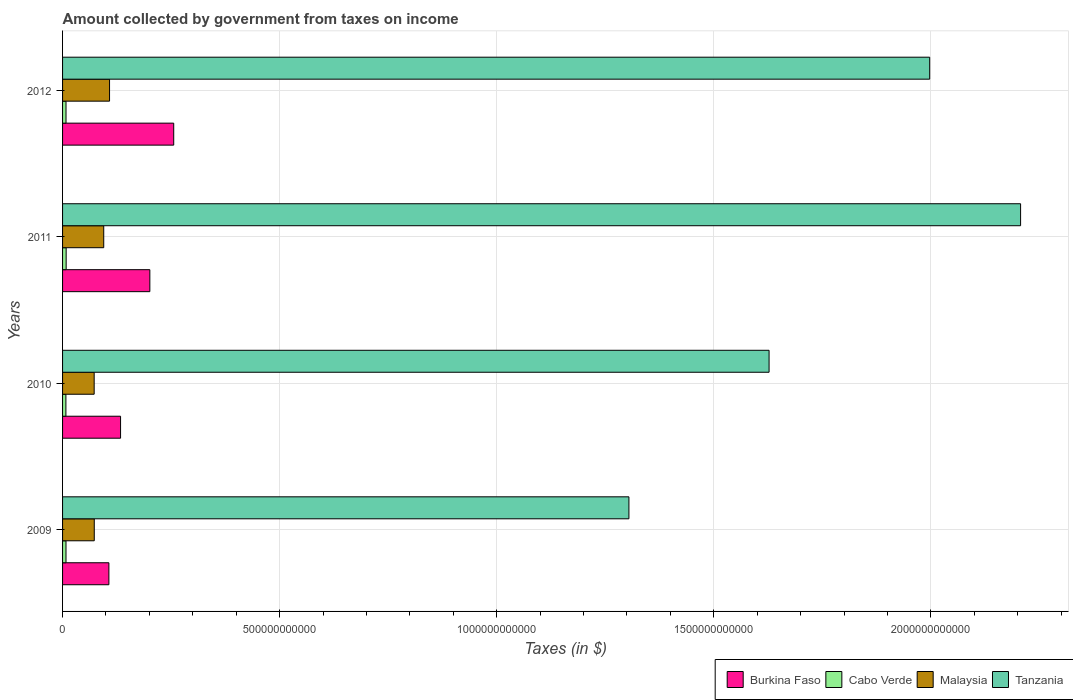How many different coloured bars are there?
Your response must be concise. 4. Are the number of bars per tick equal to the number of legend labels?
Your answer should be very brief. Yes. How many bars are there on the 4th tick from the top?
Your answer should be compact. 4. In how many cases, is the number of bars for a given year not equal to the number of legend labels?
Give a very brief answer. 0. What is the amount collected by government from taxes on income in Cabo Verde in 2011?
Provide a short and direct response. 8.28e+09. Across all years, what is the maximum amount collected by government from taxes on income in Malaysia?
Your answer should be compact. 1.08e+11. Across all years, what is the minimum amount collected by government from taxes on income in Burkina Faso?
Offer a very short reply. 1.07e+11. What is the total amount collected by government from taxes on income in Cabo Verde in the graph?
Your response must be concise. 3.18e+1. What is the difference between the amount collected by government from taxes on income in Malaysia in 2011 and that in 2012?
Provide a short and direct response. -1.34e+1. What is the difference between the amount collected by government from taxes on income in Cabo Verde in 2010 and the amount collected by government from taxes on income in Tanzania in 2009?
Your response must be concise. -1.30e+12. What is the average amount collected by government from taxes on income in Malaysia per year?
Ensure brevity in your answer.  8.72e+1. In the year 2012, what is the difference between the amount collected by government from taxes on income in Malaysia and amount collected by government from taxes on income in Burkina Faso?
Your answer should be compact. -1.48e+11. What is the ratio of the amount collected by government from taxes on income in Tanzania in 2010 to that in 2011?
Your answer should be compact. 0.74. What is the difference between the highest and the second highest amount collected by government from taxes on income in Burkina Faso?
Give a very brief answer. 5.50e+1. What is the difference between the highest and the lowest amount collected by government from taxes on income in Burkina Faso?
Your response must be concise. 1.49e+11. What does the 4th bar from the top in 2009 represents?
Give a very brief answer. Burkina Faso. What does the 3rd bar from the bottom in 2010 represents?
Give a very brief answer. Malaysia. Are all the bars in the graph horizontal?
Provide a succinct answer. Yes. How many years are there in the graph?
Your response must be concise. 4. What is the difference between two consecutive major ticks on the X-axis?
Provide a succinct answer. 5.00e+11. Does the graph contain any zero values?
Offer a very short reply. No. How many legend labels are there?
Your answer should be compact. 4. What is the title of the graph?
Your response must be concise. Amount collected by government from taxes on income. What is the label or title of the X-axis?
Provide a succinct answer. Taxes (in $). What is the label or title of the Y-axis?
Give a very brief answer. Years. What is the Taxes (in $) in Burkina Faso in 2009?
Offer a terse response. 1.07e+11. What is the Taxes (in $) in Cabo Verde in 2009?
Offer a terse response. 7.91e+09. What is the Taxes (in $) in Malaysia in 2009?
Offer a very short reply. 7.30e+1. What is the Taxes (in $) in Tanzania in 2009?
Keep it short and to the point. 1.30e+12. What is the Taxes (in $) of Burkina Faso in 2010?
Provide a succinct answer. 1.34e+11. What is the Taxes (in $) of Cabo Verde in 2010?
Offer a very short reply. 7.70e+09. What is the Taxes (in $) in Malaysia in 2010?
Offer a terse response. 7.28e+1. What is the Taxes (in $) of Tanzania in 2010?
Your answer should be compact. 1.63e+12. What is the Taxes (in $) of Burkina Faso in 2011?
Your answer should be very brief. 2.01e+11. What is the Taxes (in $) in Cabo Verde in 2011?
Your answer should be very brief. 8.28e+09. What is the Taxes (in $) of Malaysia in 2011?
Offer a terse response. 9.48e+1. What is the Taxes (in $) of Tanzania in 2011?
Your answer should be compact. 2.21e+12. What is the Taxes (in $) of Burkina Faso in 2012?
Your answer should be compact. 2.56e+11. What is the Taxes (in $) of Cabo Verde in 2012?
Make the answer very short. 7.94e+09. What is the Taxes (in $) of Malaysia in 2012?
Your response must be concise. 1.08e+11. What is the Taxes (in $) of Tanzania in 2012?
Provide a short and direct response. 2.00e+12. Across all years, what is the maximum Taxes (in $) of Burkina Faso?
Your answer should be compact. 2.56e+11. Across all years, what is the maximum Taxes (in $) of Cabo Verde?
Your answer should be very brief. 8.28e+09. Across all years, what is the maximum Taxes (in $) of Malaysia?
Your response must be concise. 1.08e+11. Across all years, what is the maximum Taxes (in $) in Tanzania?
Your response must be concise. 2.21e+12. Across all years, what is the minimum Taxes (in $) of Burkina Faso?
Provide a succinct answer. 1.07e+11. Across all years, what is the minimum Taxes (in $) of Cabo Verde?
Make the answer very short. 7.70e+09. Across all years, what is the minimum Taxes (in $) of Malaysia?
Make the answer very short. 7.28e+1. Across all years, what is the minimum Taxes (in $) of Tanzania?
Provide a succinct answer. 1.30e+12. What is the total Taxes (in $) in Burkina Faso in the graph?
Ensure brevity in your answer.  6.97e+11. What is the total Taxes (in $) in Cabo Verde in the graph?
Offer a terse response. 3.18e+1. What is the total Taxes (in $) in Malaysia in the graph?
Give a very brief answer. 3.49e+11. What is the total Taxes (in $) in Tanzania in the graph?
Offer a very short reply. 7.14e+12. What is the difference between the Taxes (in $) of Burkina Faso in 2009 and that in 2010?
Your response must be concise. -2.69e+1. What is the difference between the Taxes (in $) in Cabo Verde in 2009 and that in 2010?
Offer a very short reply. 2.10e+08. What is the difference between the Taxes (in $) in Malaysia in 2009 and that in 2010?
Ensure brevity in your answer.  2.37e+08. What is the difference between the Taxes (in $) of Tanzania in 2009 and that in 2010?
Your answer should be very brief. -3.23e+11. What is the difference between the Taxes (in $) in Burkina Faso in 2009 and that in 2011?
Provide a succinct answer. -9.43e+1. What is the difference between the Taxes (in $) of Cabo Verde in 2009 and that in 2011?
Give a very brief answer. -3.74e+08. What is the difference between the Taxes (in $) in Malaysia in 2009 and that in 2011?
Offer a terse response. -2.18e+1. What is the difference between the Taxes (in $) of Tanzania in 2009 and that in 2011?
Your answer should be compact. -9.02e+11. What is the difference between the Taxes (in $) of Burkina Faso in 2009 and that in 2012?
Your answer should be very brief. -1.49e+11. What is the difference between the Taxes (in $) of Cabo Verde in 2009 and that in 2012?
Provide a succinct answer. -2.87e+07. What is the difference between the Taxes (in $) of Malaysia in 2009 and that in 2012?
Offer a very short reply. -3.52e+1. What is the difference between the Taxes (in $) of Tanzania in 2009 and that in 2012?
Give a very brief answer. -6.93e+11. What is the difference between the Taxes (in $) in Burkina Faso in 2010 and that in 2011?
Offer a very short reply. -6.74e+1. What is the difference between the Taxes (in $) in Cabo Verde in 2010 and that in 2011?
Offer a very short reply. -5.84e+08. What is the difference between the Taxes (in $) in Malaysia in 2010 and that in 2011?
Make the answer very short. -2.21e+1. What is the difference between the Taxes (in $) of Tanzania in 2010 and that in 2011?
Your answer should be very brief. -5.79e+11. What is the difference between the Taxes (in $) of Burkina Faso in 2010 and that in 2012?
Keep it short and to the point. -1.22e+11. What is the difference between the Taxes (in $) of Cabo Verde in 2010 and that in 2012?
Offer a terse response. -2.39e+08. What is the difference between the Taxes (in $) in Malaysia in 2010 and that in 2012?
Make the answer very short. -3.54e+1. What is the difference between the Taxes (in $) in Tanzania in 2010 and that in 2012?
Your answer should be compact. -3.70e+11. What is the difference between the Taxes (in $) in Burkina Faso in 2011 and that in 2012?
Provide a succinct answer. -5.50e+1. What is the difference between the Taxes (in $) of Cabo Verde in 2011 and that in 2012?
Your response must be concise. 3.46e+08. What is the difference between the Taxes (in $) of Malaysia in 2011 and that in 2012?
Provide a short and direct response. -1.34e+1. What is the difference between the Taxes (in $) of Tanzania in 2011 and that in 2012?
Offer a terse response. 2.09e+11. What is the difference between the Taxes (in $) of Burkina Faso in 2009 and the Taxes (in $) of Cabo Verde in 2010?
Your response must be concise. 9.90e+1. What is the difference between the Taxes (in $) of Burkina Faso in 2009 and the Taxes (in $) of Malaysia in 2010?
Provide a succinct answer. 3.39e+1. What is the difference between the Taxes (in $) in Burkina Faso in 2009 and the Taxes (in $) in Tanzania in 2010?
Provide a short and direct response. -1.52e+12. What is the difference between the Taxes (in $) of Cabo Verde in 2009 and the Taxes (in $) of Malaysia in 2010?
Provide a succinct answer. -6.49e+1. What is the difference between the Taxes (in $) of Cabo Verde in 2009 and the Taxes (in $) of Tanzania in 2010?
Give a very brief answer. -1.62e+12. What is the difference between the Taxes (in $) in Malaysia in 2009 and the Taxes (in $) in Tanzania in 2010?
Ensure brevity in your answer.  -1.55e+12. What is the difference between the Taxes (in $) in Burkina Faso in 2009 and the Taxes (in $) in Cabo Verde in 2011?
Make the answer very short. 9.84e+1. What is the difference between the Taxes (in $) of Burkina Faso in 2009 and the Taxes (in $) of Malaysia in 2011?
Provide a succinct answer. 1.18e+1. What is the difference between the Taxes (in $) of Burkina Faso in 2009 and the Taxes (in $) of Tanzania in 2011?
Offer a very short reply. -2.10e+12. What is the difference between the Taxes (in $) in Cabo Verde in 2009 and the Taxes (in $) in Malaysia in 2011?
Your response must be concise. -8.69e+1. What is the difference between the Taxes (in $) in Cabo Verde in 2009 and the Taxes (in $) in Tanzania in 2011?
Keep it short and to the point. -2.20e+12. What is the difference between the Taxes (in $) in Malaysia in 2009 and the Taxes (in $) in Tanzania in 2011?
Your answer should be compact. -2.13e+12. What is the difference between the Taxes (in $) in Burkina Faso in 2009 and the Taxes (in $) in Cabo Verde in 2012?
Your answer should be very brief. 9.87e+1. What is the difference between the Taxes (in $) in Burkina Faso in 2009 and the Taxes (in $) in Malaysia in 2012?
Provide a short and direct response. -1.51e+09. What is the difference between the Taxes (in $) in Burkina Faso in 2009 and the Taxes (in $) in Tanzania in 2012?
Give a very brief answer. -1.89e+12. What is the difference between the Taxes (in $) of Cabo Verde in 2009 and the Taxes (in $) of Malaysia in 2012?
Provide a short and direct response. -1.00e+11. What is the difference between the Taxes (in $) of Cabo Verde in 2009 and the Taxes (in $) of Tanzania in 2012?
Your answer should be very brief. -1.99e+12. What is the difference between the Taxes (in $) in Malaysia in 2009 and the Taxes (in $) in Tanzania in 2012?
Make the answer very short. -1.92e+12. What is the difference between the Taxes (in $) in Burkina Faso in 2010 and the Taxes (in $) in Cabo Verde in 2011?
Offer a terse response. 1.25e+11. What is the difference between the Taxes (in $) in Burkina Faso in 2010 and the Taxes (in $) in Malaysia in 2011?
Your answer should be compact. 3.87e+1. What is the difference between the Taxes (in $) of Burkina Faso in 2010 and the Taxes (in $) of Tanzania in 2011?
Offer a terse response. -2.07e+12. What is the difference between the Taxes (in $) of Cabo Verde in 2010 and the Taxes (in $) of Malaysia in 2011?
Offer a very short reply. -8.71e+1. What is the difference between the Taxes (in $) in Cabo Verde in 2010 and the Taxes (in $) in Tanzania in 2011?
Give a very brief answer. -2.20e+12. What is the difference between the Taxes (in $) in Malaysia in 2010 and the Taxes (in $) in Tanzania in 2011?
Provide a short and direct response. -2.13e+12. What is the difference between the Taxes (in $) in Burkina Faso in 2010 and the Taxes (in $) in Cabo Verde in 2012?
Give a very brief answer. 1.26e+11. What is the difference between the Taxes (in $) of Burkina Faso in 2010 and the Taxes (in $) of Malaysia in 2012?
Your answer should be very brief. 2.54e+1. What is the difference between the Taxes (in $) in Burkina Faso in 2010 and the Taxes (in $) in Tanzania in 2012?
Your answer should be very brief. -1.86e+12. What is the difference between the Taxes (in $) of Cabo Verde in 2010 and the Taxes (in $) of Malaysia in 2012?
Provide a short and direct response. -1.00e+11. What is the difference between the Taxes (in $) of Cabo Verde in 2010 and the Taxes (in $) of Tanzania in 2012?
Your answer should be compact. -1.99e+12. What is the difference between the Taxes (in $) of Malaysia in 2010 and the Taxes (in $) of Tanzania in 2012?
Your answer should be compact. -1.92e+12. What is the difference between the Taxes (in $) of Burkina Faso in 2011 and the Taxes (in $) of Cabo Verde in 2012?
Provide a succinct answer. 1.93e+11. What is the difference between the Taxes (in $) in Burkina Faso in 2011 and the Taxes (in $) in Malaysia in 2012?
Provide a short and direct response. 9.28e+1. What is the difference between the Taxes (in $) in Burkina Faso in 2011 and the Taxes (in $) in Tanzania in 2012?
Provide a succinct answer. -1.80e+12. What is the difference between the Taxes (in $) of Cabo Verde in 2011 and the Taxes (in $) of Malaysia in 2012?
Offer a very short reply. -9.99e+1. What is the difference between the Taxes (in $) in Cabo Verde in 2011 and the Taxes (in $) in Tanzania in 2012?
Keep it short and to the point. -1.99e+12. What is the difference between the Taxes (in $) of Malaysia in 2011 and the Taxes (in $) of Tanzania in 2012?
Your answer should be compact. -1.90e+12. What is the average Taxes (in $) of Burkina Faso per year?
Your answer should be very brief. 1.74e+11. What is the average Taxes (in $) in Cabo Verde per year?
Offer a very short reply. 7.96e+09. What is the average Taxes (in $) in Malaysia per year?
Your answer should be compact. 8.72e+1. What is the average Taxes (in $) in Tanzania per year?
Your answer should be compact. 1.78e+12. In the year 2009, what is the difference between the Taxes (in $) in Burkina Faso and Taxes (in $) in Cabo Verde?
Provide a succinct answer. 9.88e+1. In the year 2009, what is the difference between the Taxes (in $) in Burkina Faso and Taxes (in $) in Malaysia?
Make the answer very short. 3.37e+1. In the year 2009, what is the difference between the Taxes (in $) of Burkina Faso and Taxes (in $) of Tanzania?
Provide a succinct answer. -1.20e+12. In the year 2009, what is the difference between the Taxes (in $) of Cabo Verde and Taxes (in $) of Malaysia?
Make the answer very short. -6.51e+1. In the year 2009, what is the difference between the Taxes (in $) in Cabo Verde and Taxes (in $) in Tanzania?
Your answer should be compact. -1.30e+12. In the year 2009, what is the difference between the Taxes (in $) in Malaysia and Taxes (in $) in Tanzania?
Give a very brief answer. -1.23e+12. In the year 2010, what is the difference between the Taxes (in $) of Burkina Faso and Taxes (in $) of Cabo Verde?
Your answer should be compact. 1.26e+11. In the year 2010, what is the difference between the Taxes (in $) of Burkina Faso and Taxes (in $) of Malaysia?
Offer a very short reply. 6.08e+1. In the year 2010, what is the difference between the Taxes (in $) in Burkina Faso and Taxes (in $) in Tanzania?
Offer a terse response. -1.49e+12. In the year 2010, what is the difference between the Taxes (in $) in Cabo Verde and Taxes (in $) in Malaysia?
Ensure brevity in your answer.  -6.51e+1. In the year 2010, what is the difference between the Taxes (in $) in Cabo Verde and Taxes (in $) in Tanzania?
Give a very brief answer. -1.62e+12. In the year 2010, what is the difference between the Taxes (in $) of Malaysia and Taxes (in $) of Tanzania?
Offer a terse response. -1.55e+12. In the year 2011, what is the difference between the Taxes (in $) in Burkina Faso and Taxes (in $) in Cabo Verde?
Offer a terse response. 1.93e+11. In the year 2011, what is the difference between the Taxes (in $) of Burkina Faso and Taxes (in $) of Malaysia?
Give a very brief answer. 1.06e+11. In the year 2011, what is the difference between the Taxes (in $) of Burkina Faso and Taxes (in $) of Tanzania?
Your answer should be very brief. -2.01e+12. In the year 2011, what is the difference between the Taxes (in $) in Cabo Verde and Taxes (in $) in Malaysia?
Offer a very short reply. -8.66e+1. In the year 2011, what is the difference between the Taxes (in $) of Cabo Verde and Taxes (in $) of Tanzania?
Offer a terse response. -2.20e+12. In the year 2011, what is the difference between the Taxes (in $) of Malaysia and Taxes (in $) of Tanzania?
Make the answer very short. -2.11e+12. In the year 2012, what is the difference between the Taxes (in $) of Burkina Faso and Taxes (in $) of Cabo Verde?
Provide a short and direct response. 2.48e+11. In the year 2012, what is the difference between the Taxes (in $) in Burkina Faso and Taxes (in $) in Malaysia?
Your answer should be compact. 1.48e+11. In the year 2012, what is the difference between the Taxes (in $) in Burkina Faso and Taxes (in $) in Tanzania?
Provide a succinct answer. -1.74e+12. In the year 2012, what is the difference between the Taxes (in $) in Cabo Verde and Taxes (in $) in Malaysia?
Your response must be concise. -1.00e+11. In the year 2012, what is the difference between the Taxes (in $) of Cabo Verde and Taxes (in $) of Tanzania?
Provide a succinct answer. -1.99e+12. In the year 2012, what is the difference between the Taxes (in $) in Malaysia and Taxes (in $) in Tanzania?
Provide a succinct answer. -1.89e+12. What is the ratio of the Taxes (in $) in Burkina Faso in 2009 to that in 2010?
Your answer should be very brief. 0.8. What is the ratio of the Taxes (in $) of Cabo Verde in 2009 to that in 2010?
Offer a terse response. 1.03. What is the ratio of the Taxes (in $) in Tanzania in 2009 to that in 2010?
Ensure brevity in your answer.  0.8. What is the ratio of the Taxes (in $) of Burkina Faso in 2009 to that in 2011?
Your answer should be very brief. 0.53. What is the ratio of the Taxes (in $) of Cabo Verde in 2009 to that in 2011?
Your answer should be compact. 0.95. What is the ratio of the Taxes (in $) in Malaysia in 2009 to that in 2011?
Make the answer very short. 0.77. What is the ratio of the Taxes (in $) of Tanzania in 2009 to that in 2011?
Make the answer very short. 0.59. What is the ratio of the Taxes (in $) in Burkina Faso in 2009 to that in 2012?
Provide a succinct answer. 0.42. What is the ratio of the Taxes (in $) of Cabo Verde in 2009 to that in 2012?
Make the answer very short. 1. What is the ratio of the Taxes (in $) in Malaysia in 2009 to that in 2012?
Provide a short and direct response. 0.67. What is the ratio of the Taxes (in $) in Tanzania in 2009 to that in 2012?
Your answer should be very brief. 0.65. What is the ratio of the Taxes (in $) in Burkina Faso in 2010 to that in 2011?
Offer a terse response. 0.66. What is the ratio of the Taxes (in $) in Cabo Verde in 2010 to that in 2011?
Provide a succinct answer. 0.93. What is the ratio of the Taxes (in $) of Malaysia in 2010 to that in 2011?
Ensure brevity in your answer.  0.77. What is the ratio of the Taxes (in $) in Tanzania in 2010 to that in 2011?
Your answer should be very brief. 0.74. What is the ratio of the Taxes (in $) of Burkina Faso in 2010 to that in 2012?
Provide a succinct answer. 0.52. What is the ratio of the Taxes (in $) of Cabo Verde in 2010 to that in 2012?
Offer a terse response. 0.97. What is the ratio of the Taxes (in $) in Malaysia in 2010 to that in 2012?
Provide a short and direct response. 0.67. What is the ratio of the Taxes (in $) in Tanzania in 2010 to that in 2012?
Make the answer very short. 0.81. What is the ratio of the Taxes (in $) of Burkina Faso in 2011 to that in 2012?
Offer a very short reply. 0.79. What is the ratio of the Taxes (in $) in Cabo Verde in 2011 to that in 2012?
Your answer should be compact. 1.04. What is the ratio of the Taxes (in $) in Malaysia in 2011 to that in 2012?
Offer a terse response. 0.88. What is the ratio of the Taxes (in $) in Tanzania in 2011 to that in 2012?
Make the answer very short. 1.1. What is the difference between the highest and the second highest Taxes (in $) in Burkina Faso?
Provide a short and direct response. 5.50e+1. What is the difference between the highest and the second highest Taxes (in $) of Cabo Verde?
Your answer should be very brief. 3.46e+08. What is the difference between the highest and the second highest Taxes (in $) of Malaysia?
Your answer should be compact. 1.34e+1. What is the difference between the highest and the second highest Taxes (in $) in Tanzania?
Provide a short and direct response. 2.09e+11. What is the difference between the highest and the lowest Taxes (in $) of Burkina Faso?
Make the answer very short. 1.49e+11. What is the difference between the highest and the lowest Taxes (in $) in Cabo Verde?
Keep it short and to the point. 5.84e+08. What is the difference between the highest and the lowest Taxes (in $) in Malaysia?
Ensure brevity in your answer.  3.54e+1. What is the difference between the highest and the lowest Taxes (in $) of Tanzania?
Provide a succinct answer. 9.02e+11. 